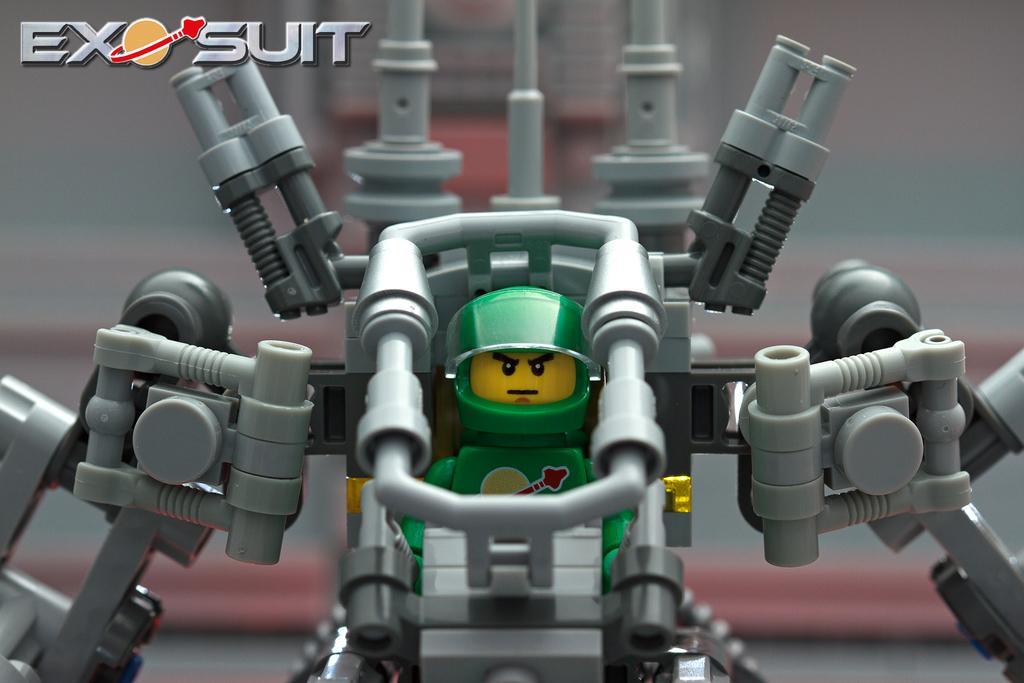Could you give a brief overview of what you see in this image? In this image we can see a robot toy and the background of the image is blurred. Here we can see the watermark at the top left side of the image. 